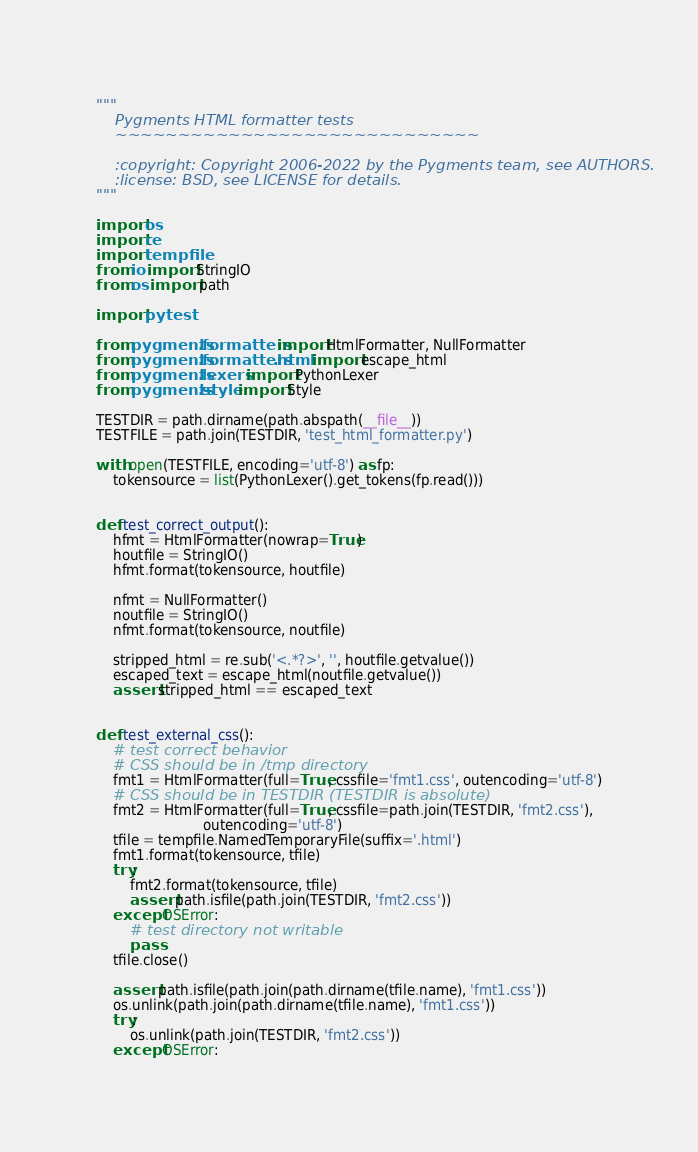<code> <loc_0><loc_0><loc_500><loc_500><_Python_>"""
    Pygments HTML formatter tests
    ~~~~~~~~~~~~~~~~~~~~~~~~~~~~~

    :copyright: Copyright 2006-2022 by the Pygments team, see AUTHORS.
    :license: BSD, see LICENSE for details.
"""

import os
import re
import tempfile
from io import StringIO
from os import path

import pytest

from pygments.formatters import HtmlFormatter, NullFormatter
from pygments.formatters.html import escape_html
from pygments.lexers import PythonLexer
from pygments.style import Style

TESTDIR = path.dirname(path.abspath(__file__))
TESTFILE = path.join(TESTDIR, 'test_html_formatter.py')

with open(TESTFILE, encoding='utf-8') as fp:
    tokensource = list(PythonLexer().get_tokens(fp.read()))


def test_correct_output():
    hfmt = HtmlFormatter(nowrap=True)
    houtfile = StringIO()
    hfmt.format(tokensource, houtfile)

    nfmt = NullFormatter()
    noutfile = StringIO()
    nfmt.format(tokensource, noutfile)

    stripped_html = re.sub('<.*?>', '', houtfile.getvalue())
    escaped_text = escape_html(noutfile.getvalue())
    assert stripped_html == escaped_text


def test_external_css():
    # test correct behavior
    # CSS should be in /tmp directory
    fmt1 = HtmlFormatter(full=True, cssfile='fmt1.css', outencoding='utf-8')
    # CSS should be in TESTDIR (TESTDIR is absolute)
    fmt2 = HtmlFormatter(full=True, cssfile=path.join(TESTDIR, 'fmt2.css'),
                         outencoding='utf-8')
    tfile = tempfile.NamedTemporaryFile(suffix='.html')
    fmt1.format(tokensource, tfile)
    try:
        fmt2.format(tokensource, tfile)
        assert path.isfile(path.join(TESTDIR, 'fmt2.css'))
    except OSError:
        # test directory not writable
        pass
    tfile.close()

    assert path.isfile(path.join(path.dirname(tfile.name), 'fmt1.css'))
    os.unlink(path.join(path.dirname(tfile.name), 'fmt1.css'))
    try:
        os.unlink(path.join(TESTDIR, 'fmt2.css'))
    except OSError:</code> 